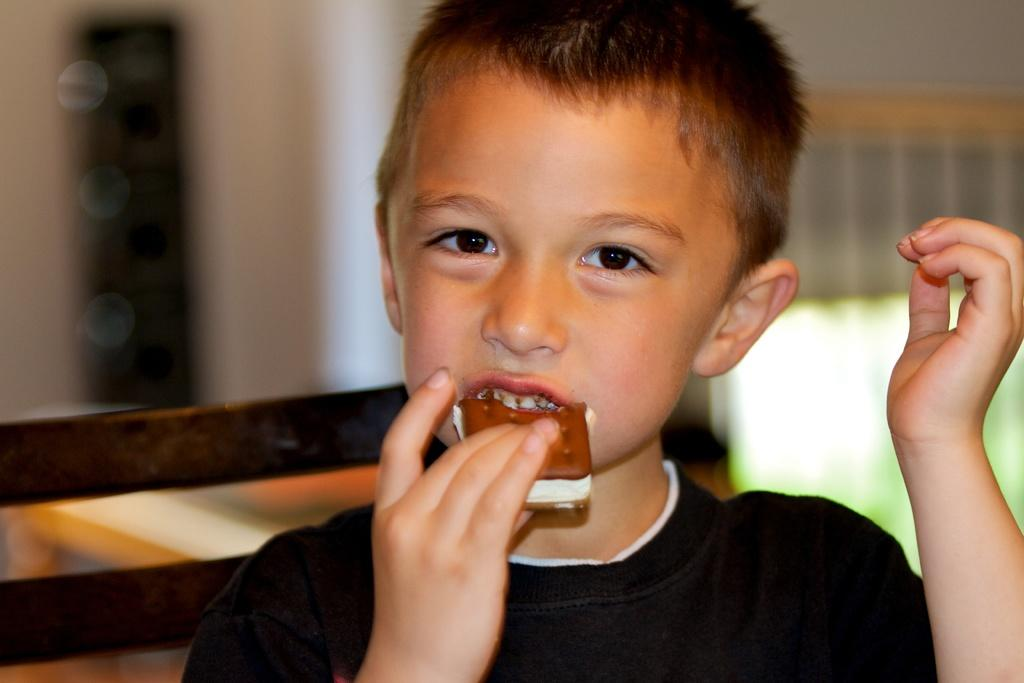What is the main subject of the image? There is a boy in the image. What is the boy holding in the image? The boy is holding a food item. Can you describe the background of the image? The background is blurry, and there are objects present. What type of goat can be seen in the image? There is no goat present in the image. What does the image smell like? The image does not have a smell, as it is a visual representation. 